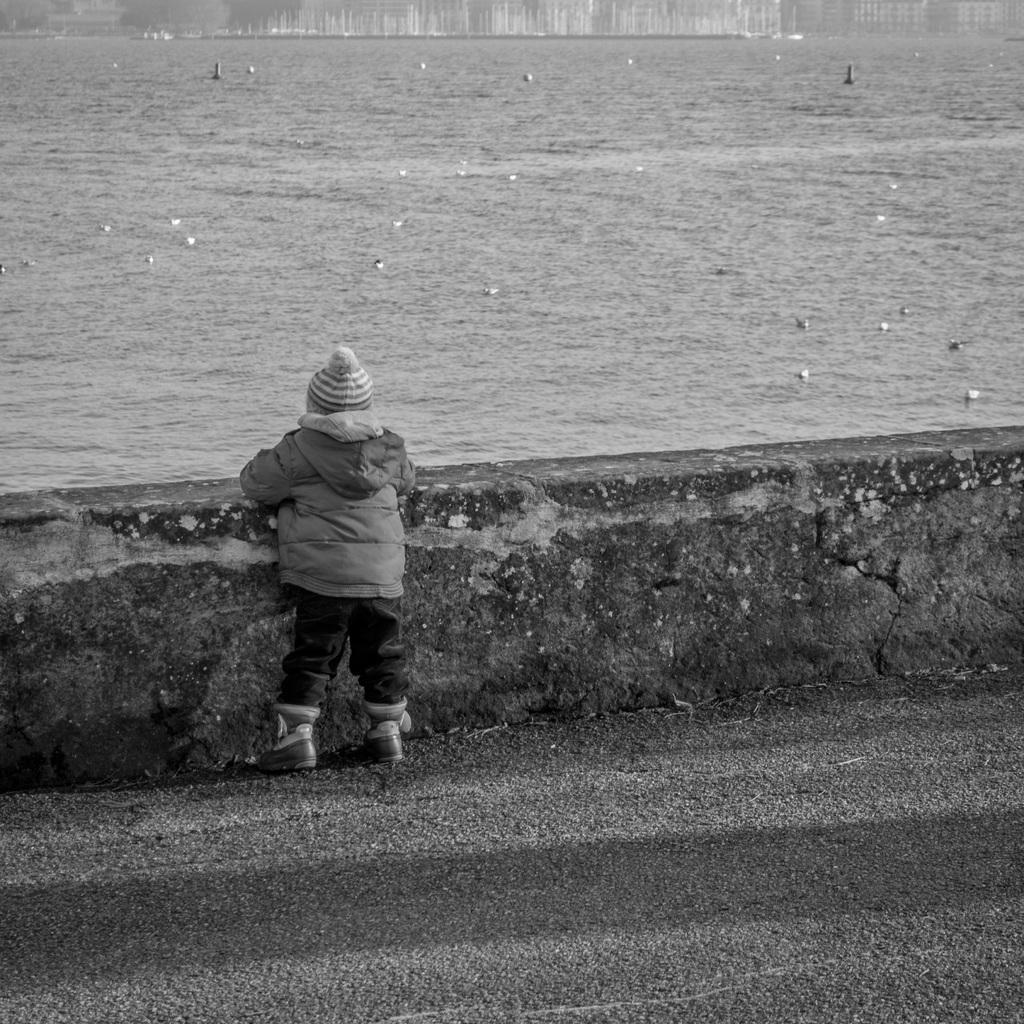What is the main subject of the image? There is a boy standing in the center of the image. What can be seen near the boy in the image? There is railing in the image. What is visible in the background of the image? There is water visible in the background of the image. What type of letters can be seen floating in the water in the image? There are no letters visible in the image, and they are not floating in the water. 